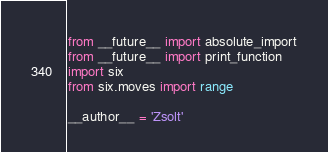Convert code to text. <code><loc_0><loc_0><loc_500><loc_500><_Python_>from __future__ import absolute_import
from __future__ import print_function
import six
from six.moves import range

__author__ = 'Zsolt'
</code> 